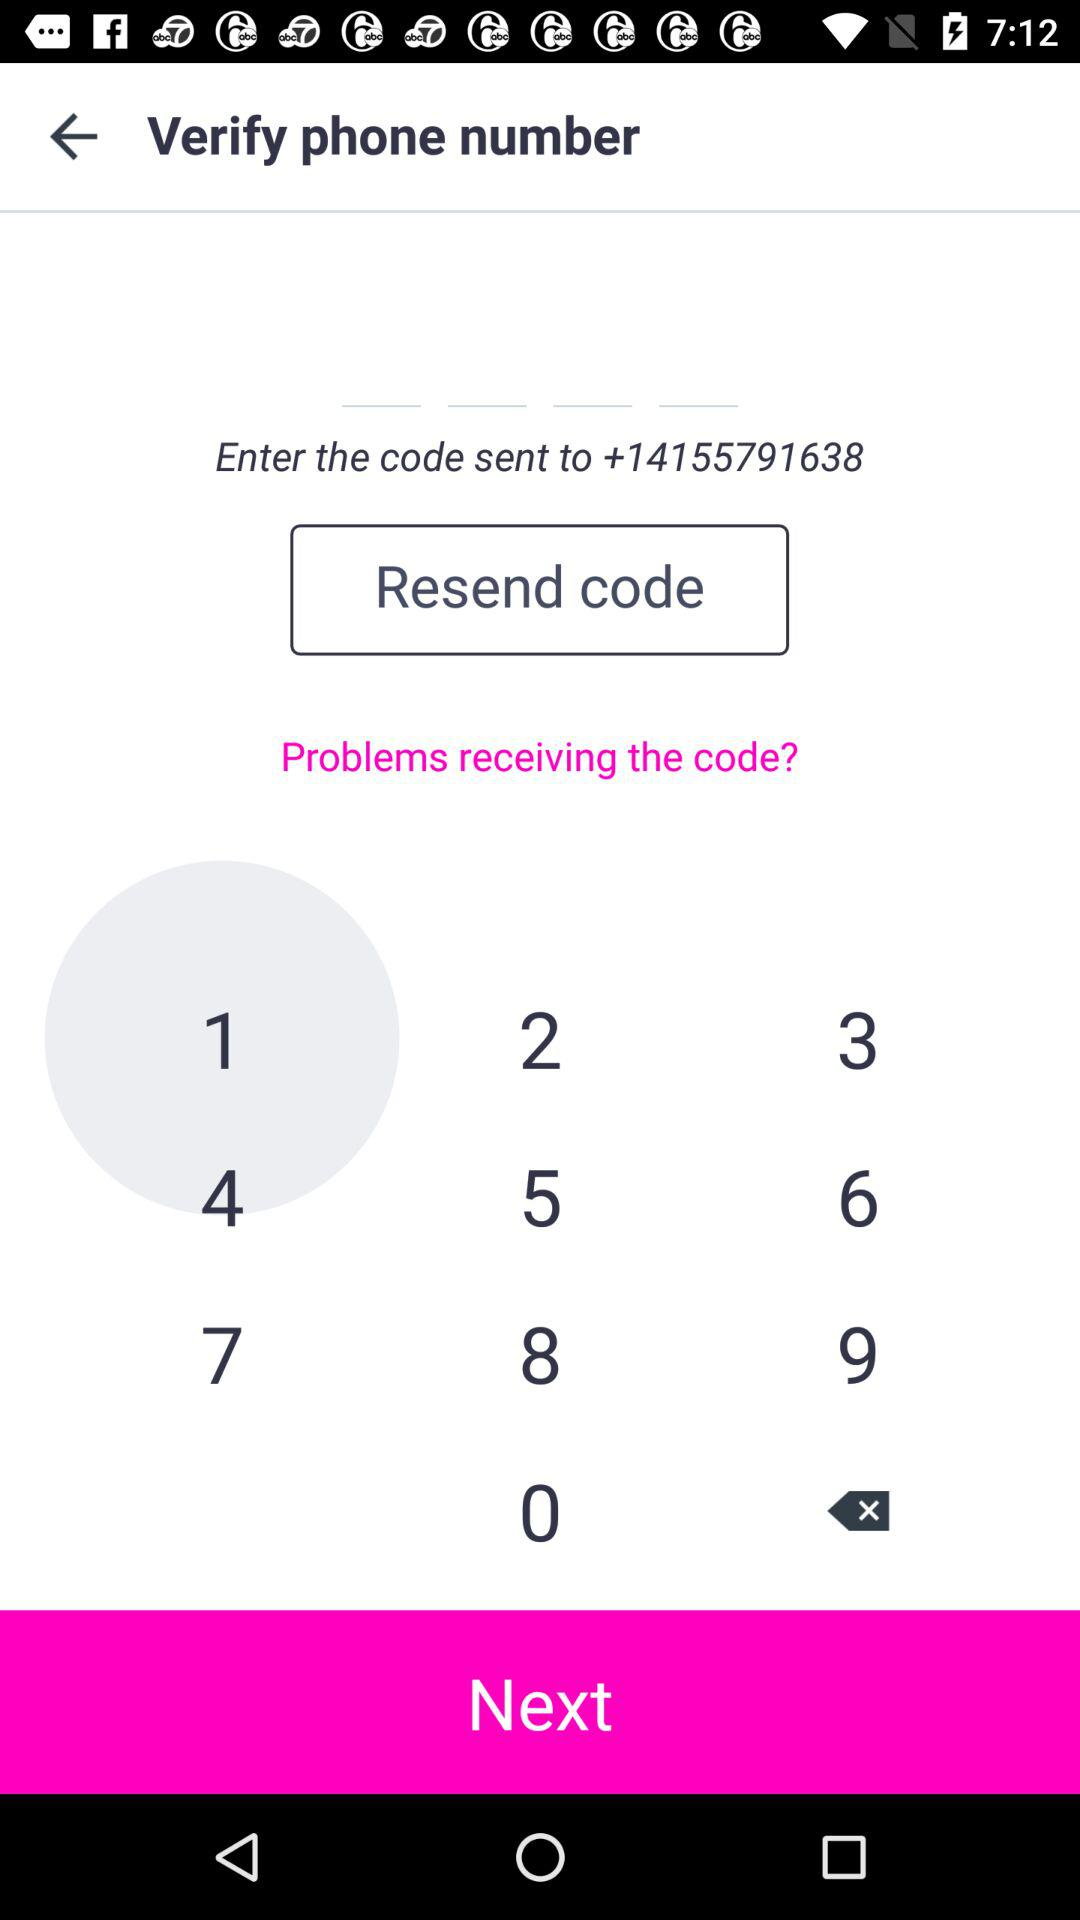What is the phone number? The phone number is +14155791638. 